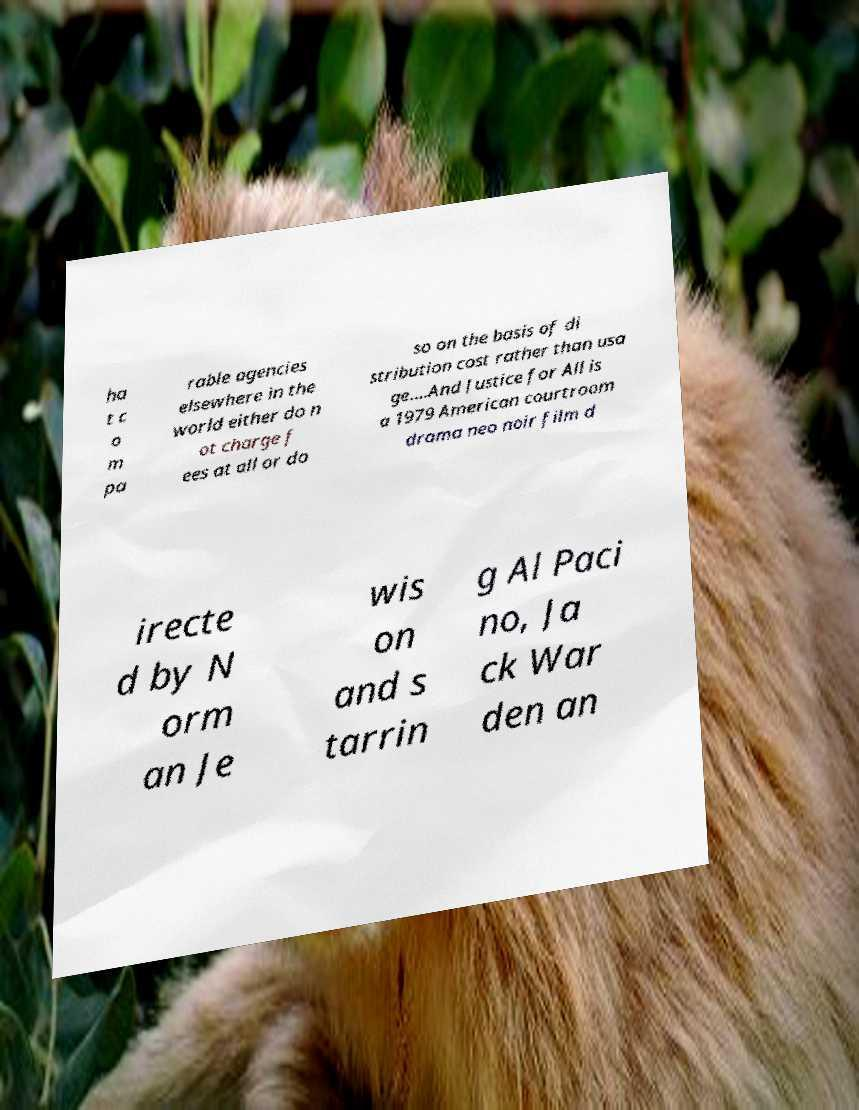I need the written content from this picture converted into text. Can you do that? ha t c o m pa rable agencies elsewhere in the world either do n ot charge f ees at all or do so on the basis of di stribution cost rather than usa ge....And Justice for All is a 1979 American courtroom drama neo noir film d irecte d by N orm an Je wis on and s tarrin g Al Paci no, Ja ck War den an 